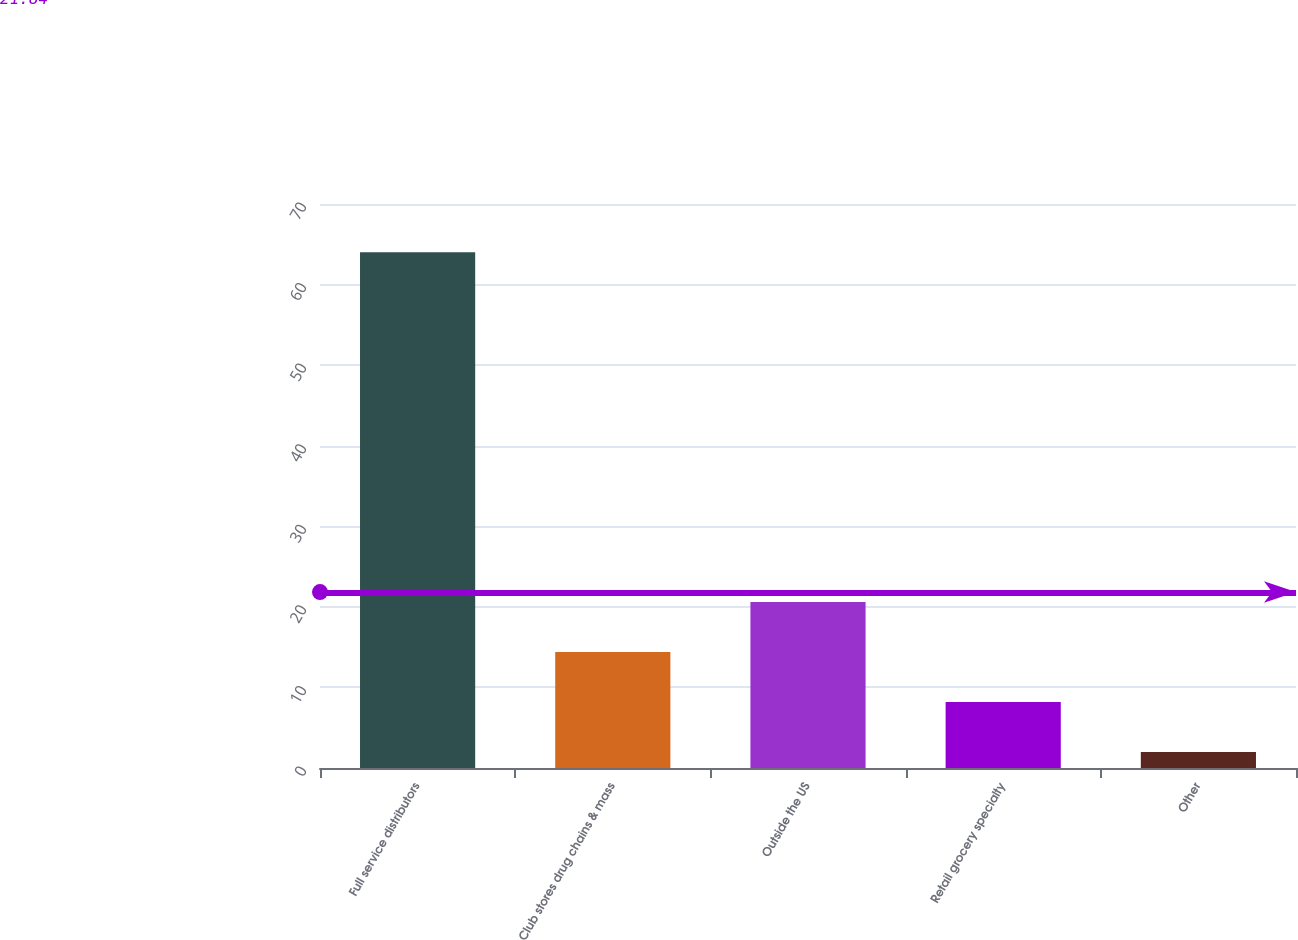Convert chart. <chart><loc_0><loc_0><loc_500><loc_500><bar_chart><fcel>Full service distributors<fcel>Club stores drug chains & mass<fcel>Outside the US<fcel>Retail grocery specialty<fcel>Other<nl><fcel>64<fcel>14.4<fcel>20.6<fcel>8.2<fcel>2<nl></chart> 